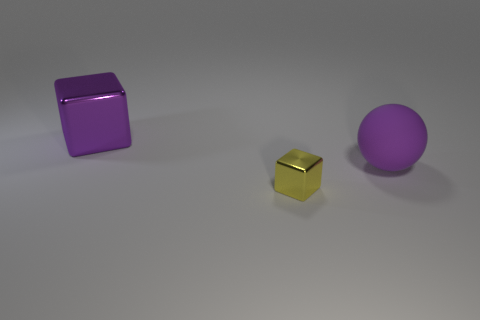There is a purple thing left of the purple object in front of the metallic object that is behind the tiny metal object; what is its material?
Offer a very short reply. Metal. Is the shape of the large object in front of the big block the same as the large purple object left of the large purple matte sphere?
Ensure brevity in your answer.  No. What is the color of the large object in front of the metal cube that is behind the yellow cube?
Offer a very short reply. Purple. How many balls are large metallic objects or tiny yellow objects?
Your response must be concise. 0. There is a shiny block on the right side of the metal block left of the yellow metallic block; what number of tiny metallic blocks are behind it?
Your answer should be compact. 0. There is a object that is the same color as the ball; what is its size?
Give a very brief answer. Large. Are there any objects made of the same material as the tiny yellow cube?
Your answer should be compact. Yes. Is the tiny yellow thing made of the same material as the large block?
Your answer should be compact. Yes. How many big rubber balls are on the left side of the large object to the left of the purple matte sphere?
Ensure brevity in your answer.  0. How many purple things are big shiny objects or metal balls?
Your answer should be compact. 1. 